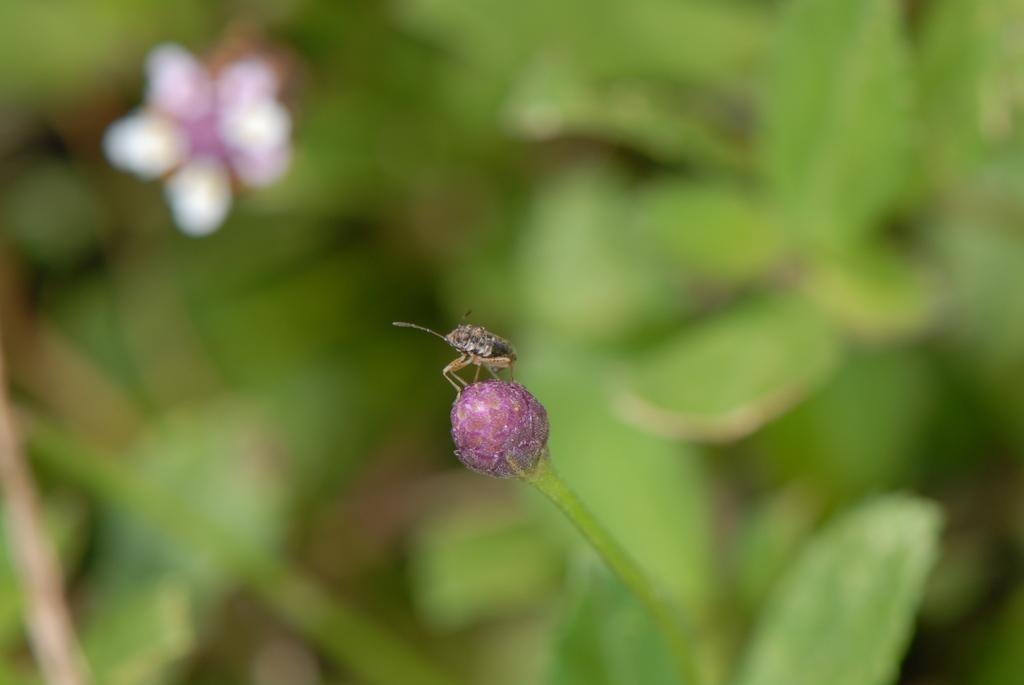What is present on the flower in the image? There is an insect on a flower in the image. What can be seen in the background of the image? There is greenery in the background of the image. What type of chalk is being used to draw on the ocean in the image? There is no ocean or chalk present in the image; it features an insect on a flower with greenery in the background. 